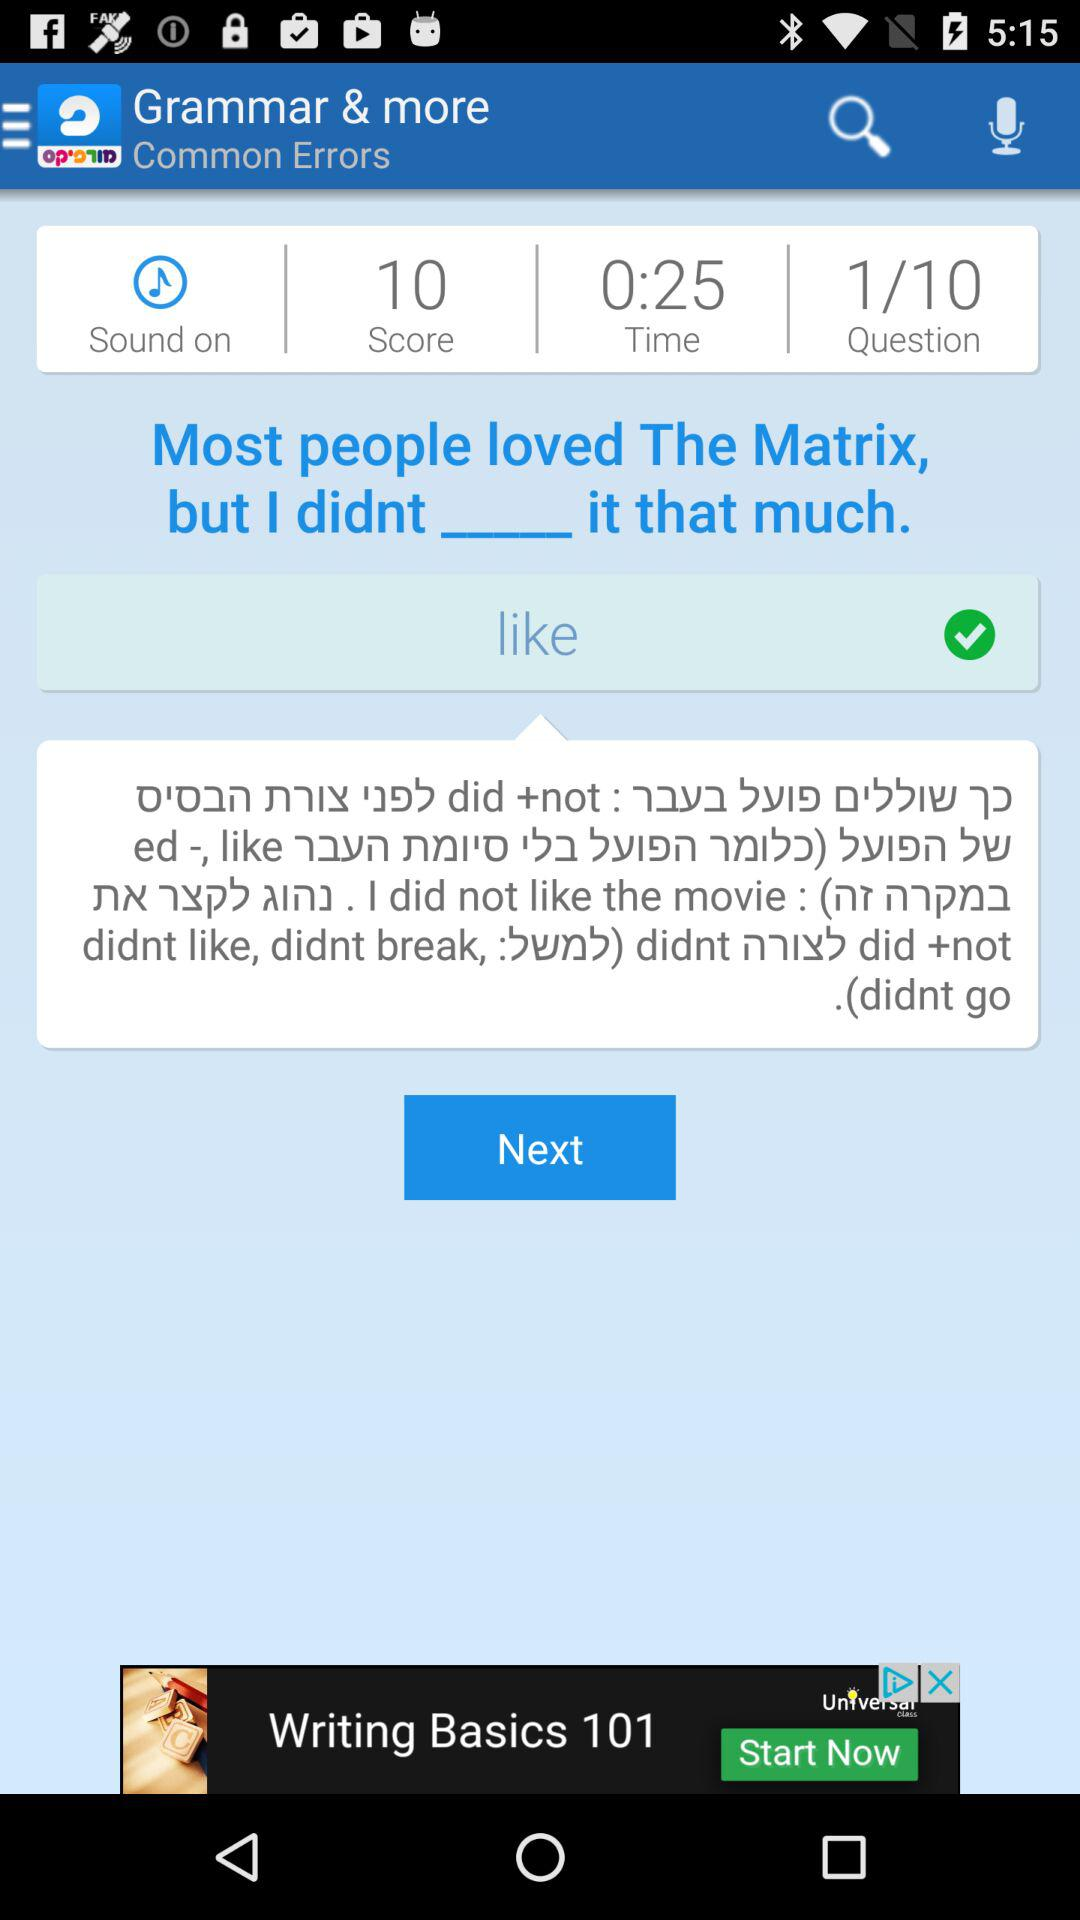What is the application name? The application name is "Morfix - English to Hebrew Tra". 